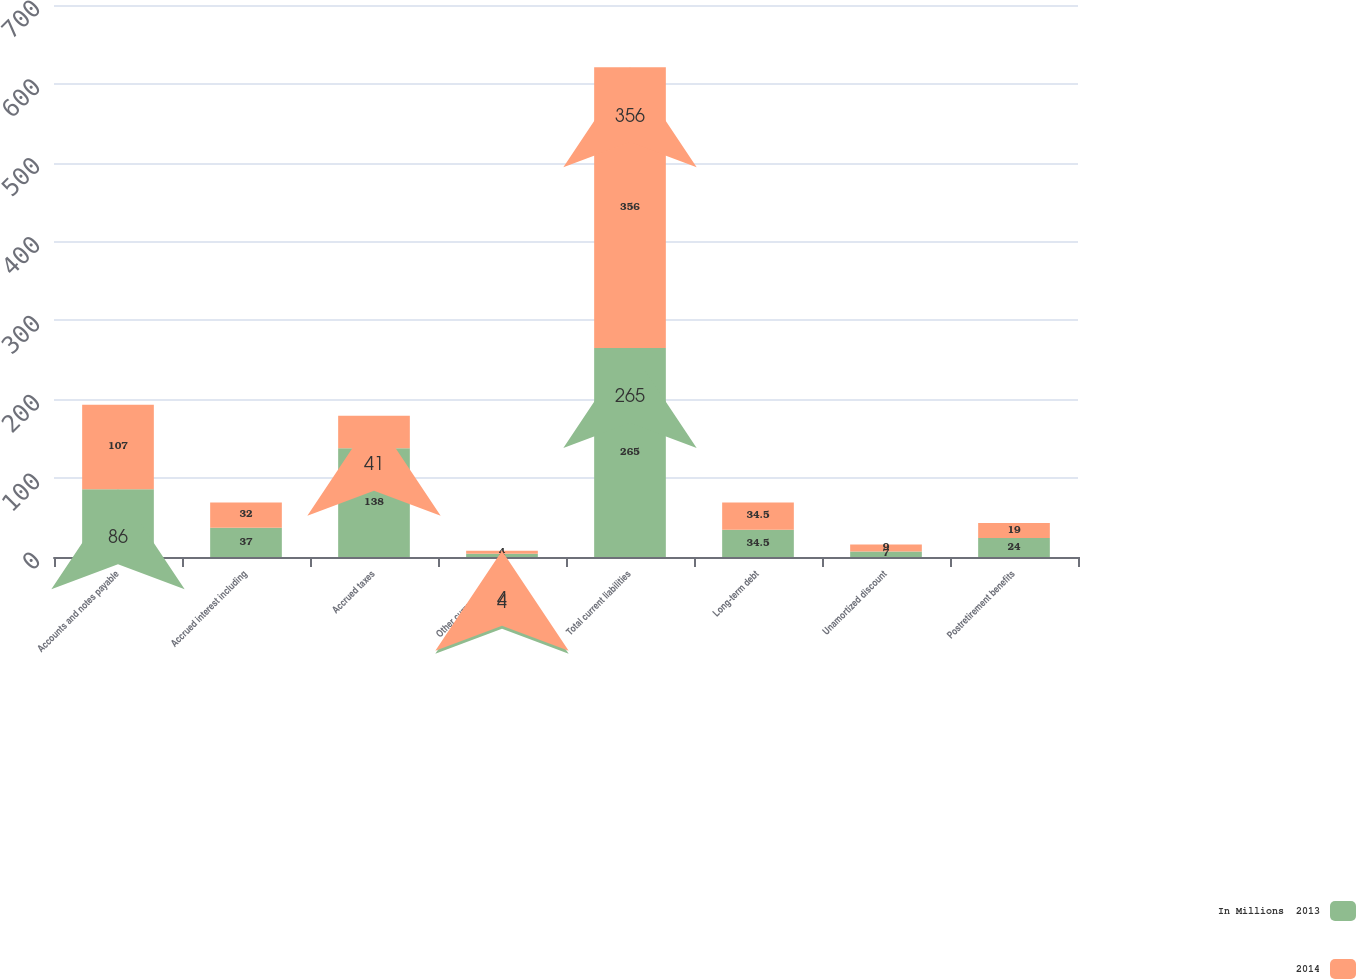Convert chart. <chart><loc_0><loc_0><loc_500><loc_500><stacked_bar_chart><ecel><fcel>Accounts and notes payable<fcel>Accrued interest including<fcel>Accrued taxes<fcel>Other current liabilities<fcel>Total current liabilities<fcel>Long-term debt<fcel>Unamortized discount<fcel>Postretirement benefits<nl><fcel>In Millions  2013<fcel>86<fcel>37<fcel>138<fcel>4<fcel>265<fcel>34.5<fcel>7<fcel>24<nl><fcel>2014<fcel>107<fcel>32<fcel>41<fcel>4<fcel>356<fcel>34.5<fcel>9<fcel>19<nl></chart> 